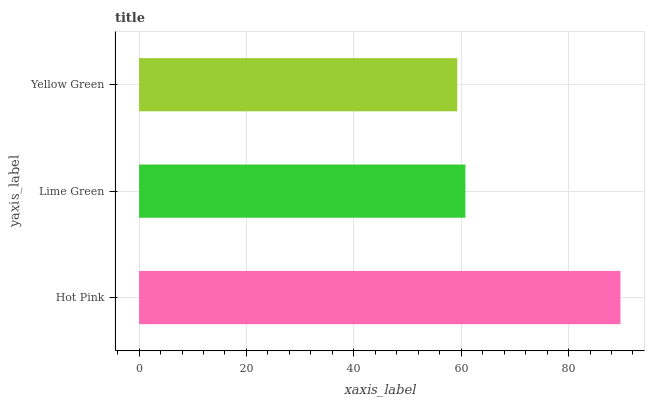Is Yellow Green the minimum?
Answer yes or no. Yes. Is Hot Pink the maximum?
Answer yes or no. Yes. Is Lime Green the minimum?
Answer yes or no. No. Is Lime Green the maximum?
Answer yes or no. No. Is Hot Pink greater than Lime Green?
Answer yes or no. Yes. Is Lime Green less than Hot Pink?
Answer yes or no. Yes. Is Lime Green greater than Hot Pink?
Answer yes or no. No. Is Hot Pink less than Lime Green?
Answer yes or no. No. Is Lime Green the high median?
Answer yes or no. Yes. Is Lime Green the low median?
Answer yes or no. Yes. Is Hot Pink the high median?
Answer yes or no. No. Is Yellow Green the low median?
Answer yes or no. No. 